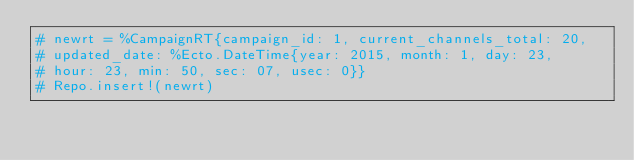Convert code to text. <code><loc_0><loc_0><loc_500><loc_500><_Elixir_># newrt = %CampaignRT{campaign_id: 1, current_channels_total: 20,
# updated_date: %Ecto.DateTime{year: 2015, month: 1, day: 23,
# hour: 23, min: 50, sec: 07, usec: 0}}
# Repo.insert!(newrt)
</code> 